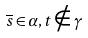<formula> <loc_0><loc_0><loc_500><loc_500>\overline { s } \in \alpha , t \notin \gamma</formula> 